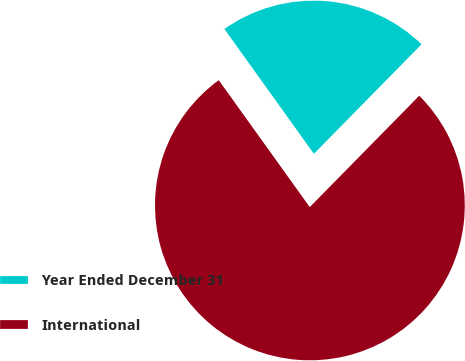Convert chart. <chart><loc_0><loc_0><loc_500><loc_500><pie_chart><fcel>Year Ended December 31<fcel>International<nl><fcel>22.26%<fcel>77.74%<nl></chart> 